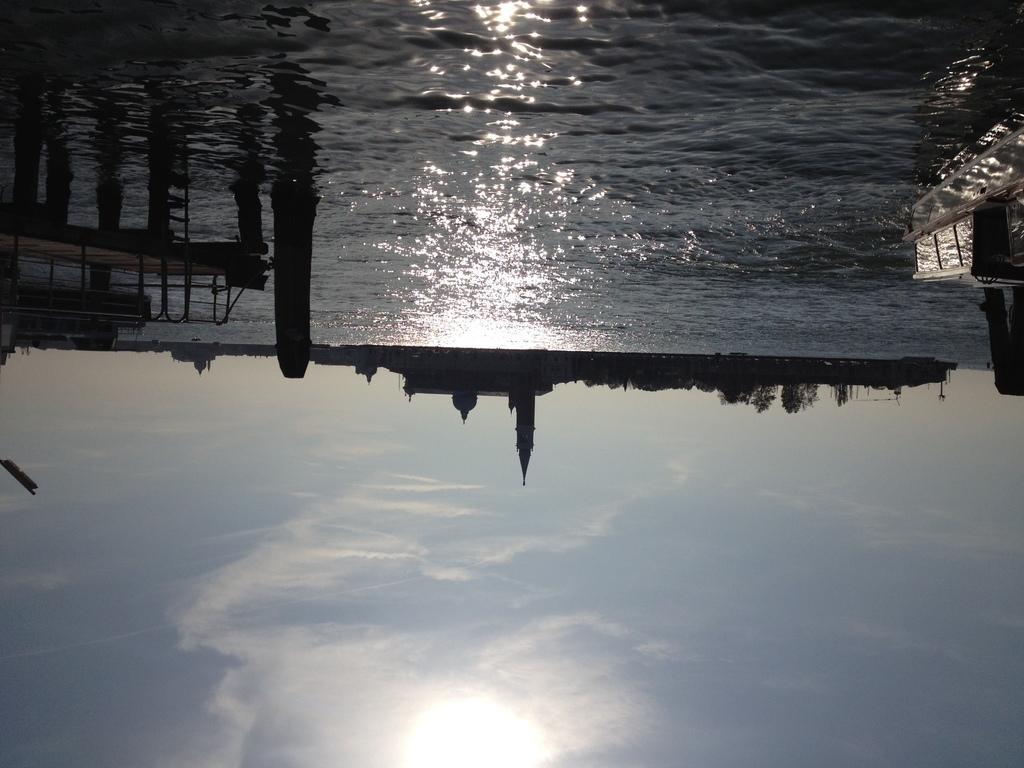Could you give a brief overview of what you see in this image? In this image there is water and we can see a board bridge. In the background there are buildings and sky. 